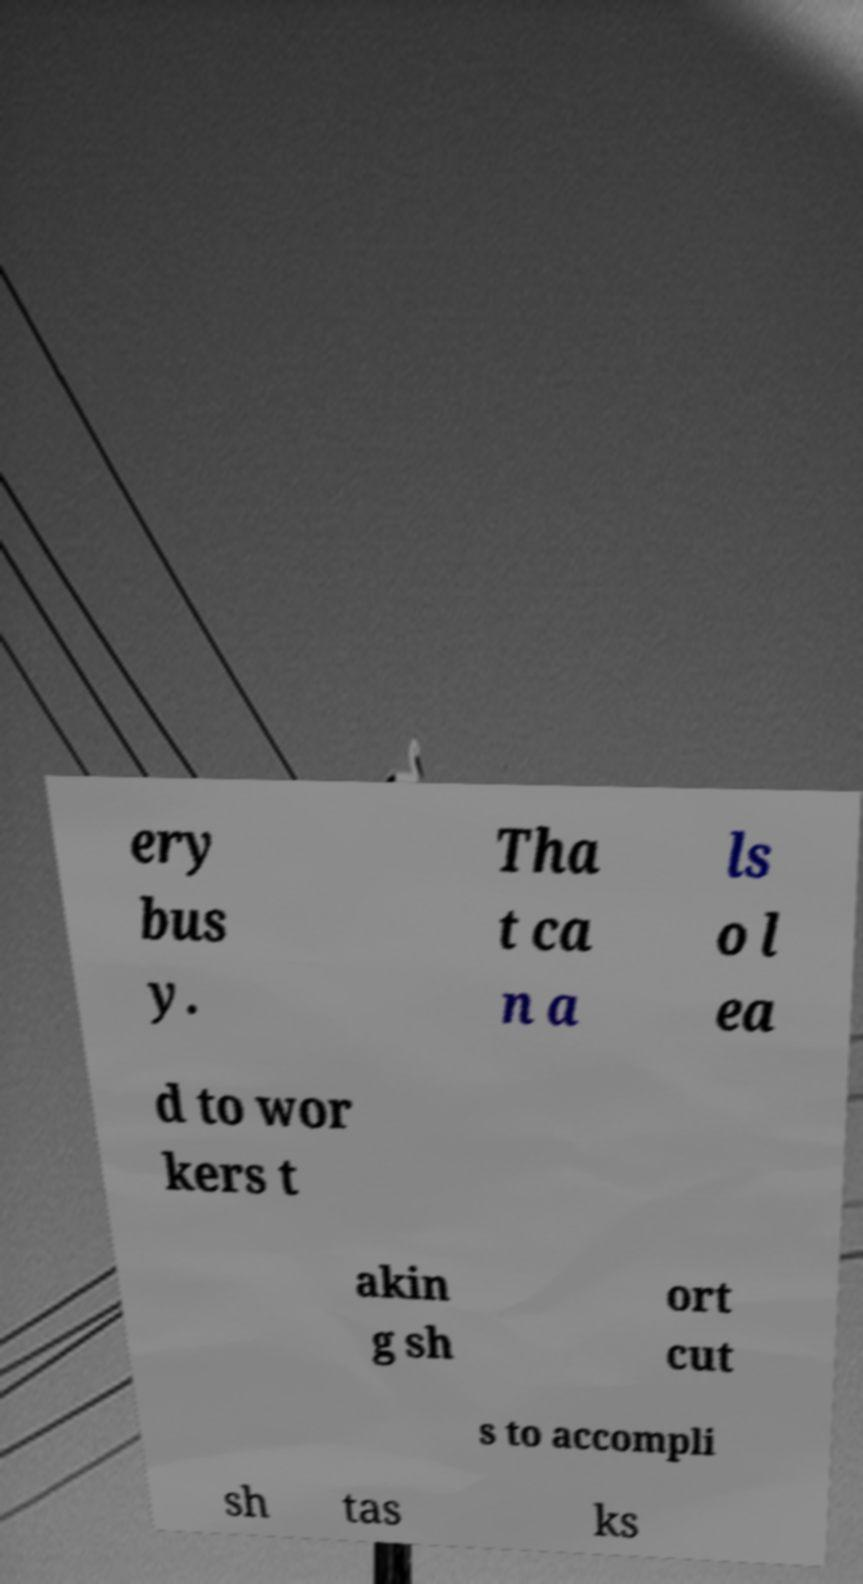What messages or text are displayed in this image? I need them in a readable, typed format. ery bus y. Tha t ca n a ls o l ea d to wor kers t akin g sh ort cut s to accompli sh tas ks 